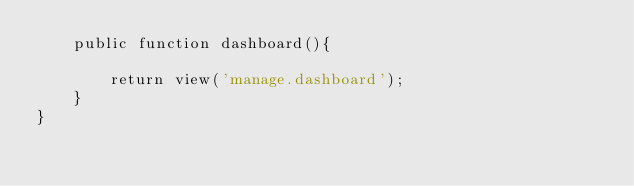Convert code to text. <code><loc_0><loc_0><loc_500><loc_500><_PHP_>    public function dashboard(){

    	return view('manage.dashboard');
    }
}
</code> 